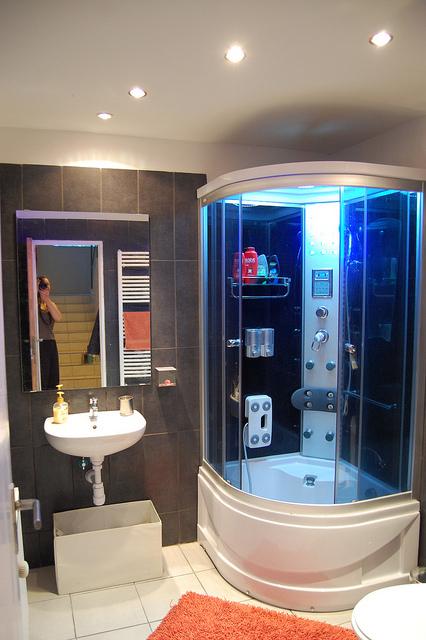Is this a typical shower?
Quick response, please. No. Is there a person in the mirror?
Quick response, please. Yes. How many recessed lights do you see in this photo?
Be succinct. 4. How many bath products are on the top rack in the shower?
Give a very brief answer. 4. 